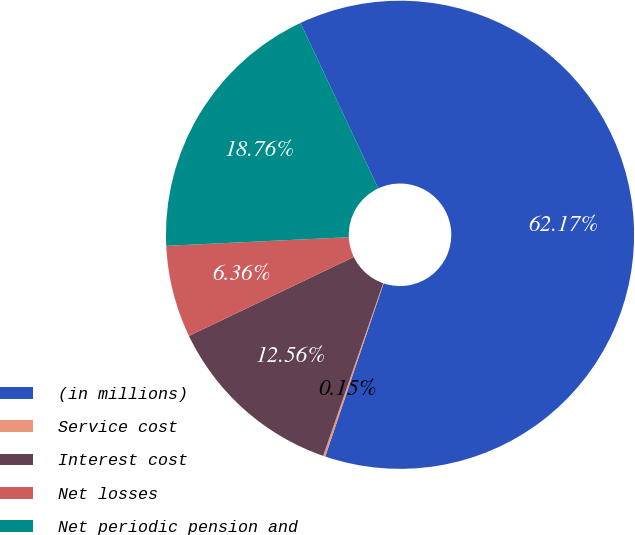Convert chart to OTSL. <chart><loc_0><loc_0><loc_500><loc_500><pie_chart><fcel>(in millions)<fcel>Service cost<fcel>Interest cost<fcel>Net losses<fcel>Net periodic pension and<nl><fcel>62.17%<fcel>0.15%<fcel>12.56%<fcel>6.36%<fcel>18.76%<nl></chart> 